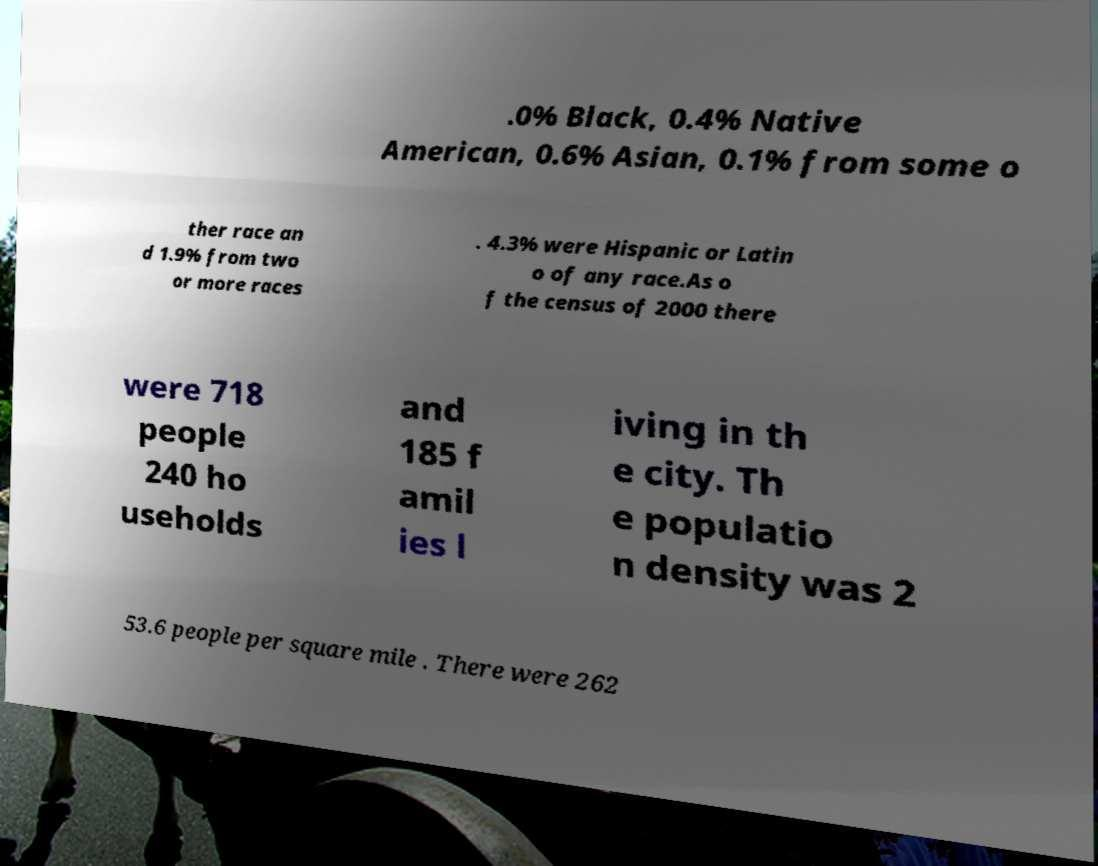What messages or text are displayed in this image? I need them in a readable, typed format. .0% Black, 0.4% Native American, 0.6% Asian, 0.1% from some o ther race an d 1.9% from two or more races . 4.3% were Hispanic or Latin o of any race.As o f the census of 2000 there were 718 people 240 ho useholds and 185 f amil ies l iving in th e city. Th e populatio n density was 2 53.6 people per square mile . There were 262 